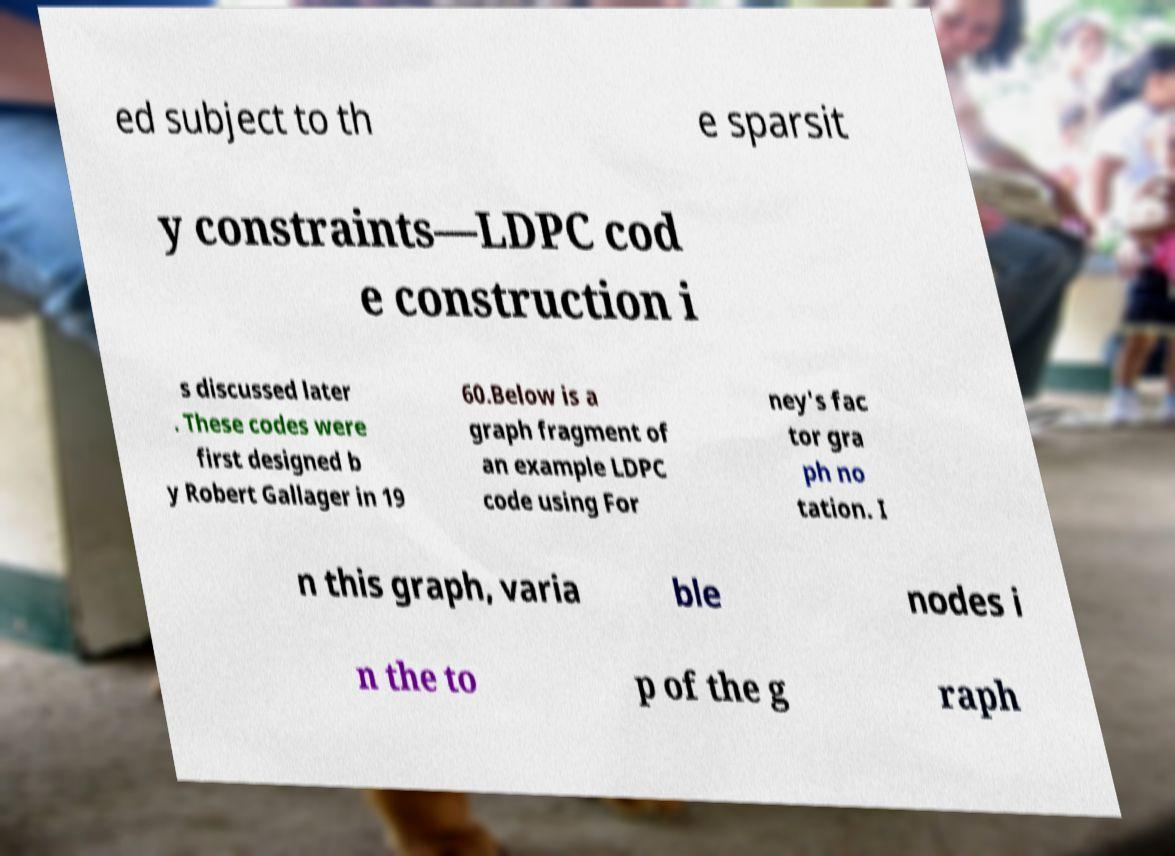Please read and relay the text visible in this image. What does it say? ed subject to th e sparsit y constraints—LDPC cod e construction i s discussed later . These codes were first designed b y Robert Gallager in 19 60.Below is a graph fragment of an example LDPC code using For ney's fac tor gra ph no tation. I n this graph, varia ble nodes i n the to p of the g raph 